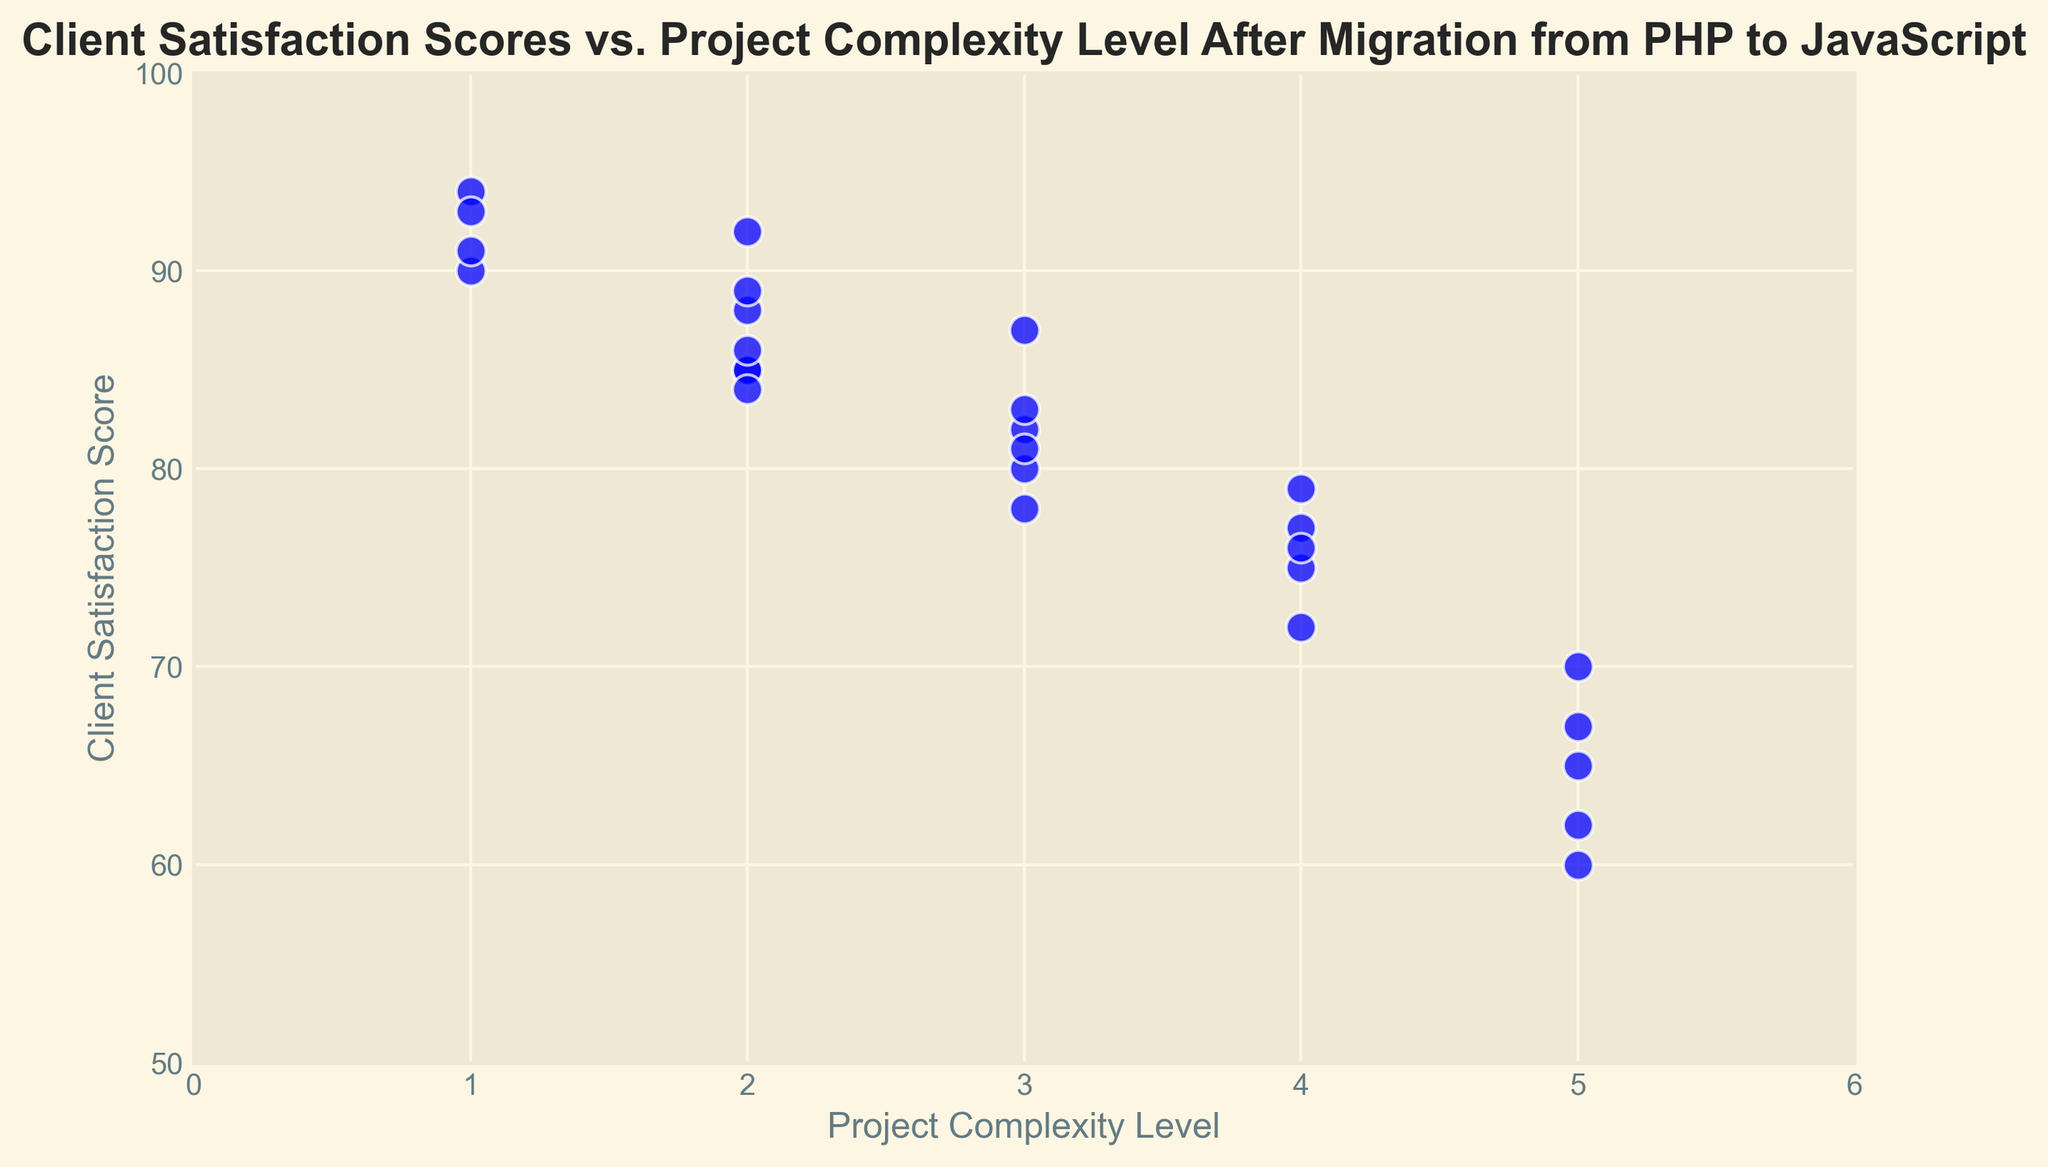What's the average Client Satisfaction Score for projects with a complexity level of 3? Identify the points with a complexity level of 3 and average their Client Satisfaction Scores. The scores are 78, 82, 80, 83, 81, and 87. Summing these gives 491, and dividing by 6 gives 81.83
Answer: 81.83 How does client satisfaction for projects with the lowest complexity level compare to those with the highest complexity level? Look for the scores of projects at complexity level 1 and 5. Complexity level 1 has scores of 90, 94, 92, 93, and 91, while complexity level 5 has scores of 60, 70, 65, 62, and 67. The average for complexity level 1 is 92 and for level 5 is 64.8. This shows much higher satisfaction for the lowest complexity level.
Answer: Higher for the lowest complexity level Is there a visual trend in client satisfaction scores as project complexity increases? Observe the scatter plot to identify any trend. Points with lower complexity levels (1 and 2) are generally higher on the satisfaction score axis, while higher complexity levels (4 and 5) show lower satisfaction scores.
Answer: Yes, it generally decreases Which complexity level appears to have the highest variation in client satisfaction scores? Compare the spread (range) of scores for each complexity level. Complexity level 5 has a wide spread from 60 to 70, showing high variation.
Answer: Level 5 How many projects have a client satisfaction score above 85? Count the individual data points where the Client Satisfaction Score is greater than 85. Points are 90, 88, 94, 92, 87, 93, and 89, 91, and 86. There are 9 such projects in total.
Answer: 9 